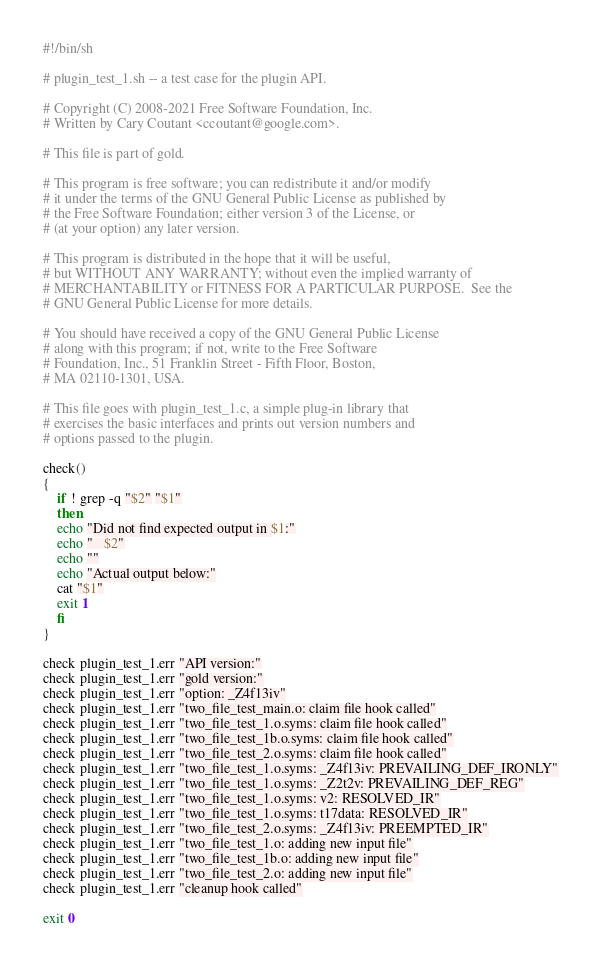<code> <loc_0><loc_0><loc_500><loc_500><_Bash_>#!/bin/sh

# plugin_test_1.sh -- a test case for the plugin API.

# Copyright (C) 2008-2021 Free Software Foundation, Inc.
# Written by Cary Coutant <ccoutant@google.com>.

# This file is part of gold.

# This program is free software; you can redistribute it and/or modify
# it under the terms of the GNU General Public License as published by
# the Free Software Foundation; either version 3 of the License, or
# (at your option) any later version.

# This program is distributed in the hope that it will be useful,
# but WITHOUT ANY WARRANTY; without even the implied warranty of
# MERCHANTABILITY or FITNESS FOR A PARTICULAR PURPOSE.  See the
# GNU General Public License for more details.

# You should have received a copy of the GNU General Public License
# along with this program; if not, write to the Free Software
# Foundation, Inc., 51 Franklin Street - Fifth Floor, Boston,
# MA 02110-1301, USA.

# This file goes with plugin_test_1.c, a simple plug-in library that
# exercises the basic interfaces and prints out version numbers and
# options passed to the plugin.

check()
{
    if ! grep -q "$2" "$1"
    then
	echo "Did not find expected output in $1:"
	echo "   $2"
	echo ""
	echo "Actual output below:"
	cat "$1"
	exit 1
    fi
}

check plugin_test_1.err "API version:"
check plugin_test_1.err "gold version:"
check plugin_test_1.err "option: _Z4f13iv"
check plugin_test_1.err "two_file_test_main.o: claim file hook called"
check plugin_test_1.err "two_file_test_1.o.syms: claim file hook called"
check plugin_test_1.err "two_file_test_1b.o.syms: claim file hook called"
check plugin_test_1.err "two_file_test_2.o.syms: claim file hook called"
check plugin_test_1.err "two_file_test_1.o.syms: _Z4f13iv: PREVAILING_DEF_IRONLY"
check plugin_test_1.err "two_file_test_1.o.syms: _Z2t2v: PREVAILING_DEF_REG"
check plugin_test_1.err "two_file_test_1.o.syms: v2: RESOLVED_IR"
check plugin_test_1.err "two_file_test_1.o.syms: t17data: RESOLVED_IR"
check plugin_test_1.err "two_file_test_2.o.syms: _Z4f13iv: PREEMPTED_IR"
check plugin_test_1.err "two_file_test_1.o: adding new input file"
check plugin_test_1.err "two_file_test_1b.o: adding new input file"
check plugin_test_1.err "two_file_test_2.o: adding new input file"
check plugin_test_1.err "cleanup hook called"

exit 0
</code> 